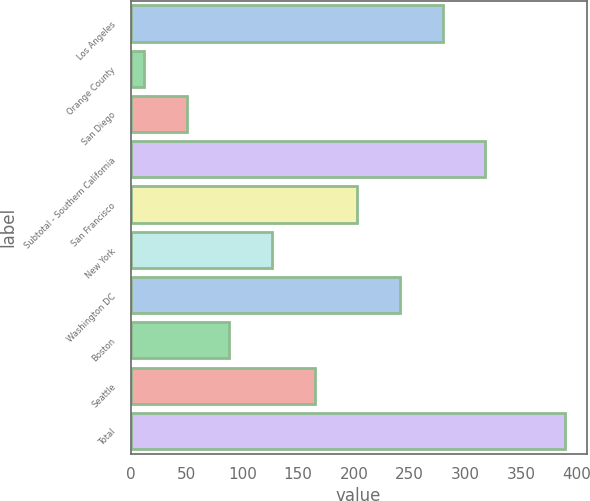Convert chart. <chart><loc_0><loc_0><loc_500><loc_500><bar_chart><fcel>Los Angeles<fcel>Orange County<fcel>San Diego<fcel>Subtotal - Southern California<fcel>San Francisco<fcel>New York<fcel>Washington DC<fcel>Boston<fcel>Seattle<fcel>Total<nl><fcel>279.4<fcel>12<fcel>50.2<fcel>317.6<fcel>203<fcel>126.6<fcel>241.2<fcel>88.4<fcel>164.8<fcel>389<nl></chart> 